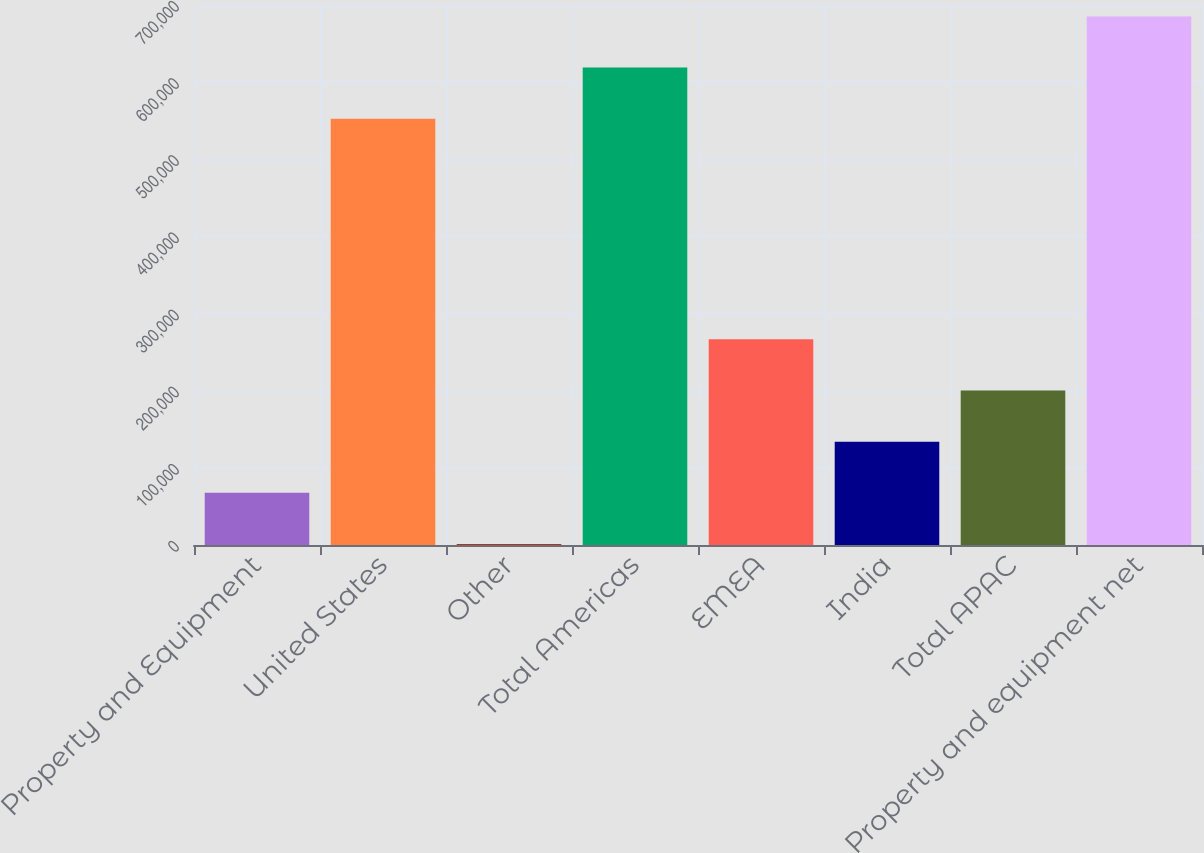<chart> <loc_0><loc_0><loc_500><loc_500><bar_chart><fcel>Property and Equipment<fcel>United States<fcel>Other<fcel>Total Americas<fcel>EMEA<fcel>India<fcel>Total APAC<fcel>Property and equipment net<nl><fcel>67713.6<fcel>552634<fcel>1426<fcel>618922<fcel>266576<fcel>134001<fcel>200289<fcel>685209<nl></chart> 